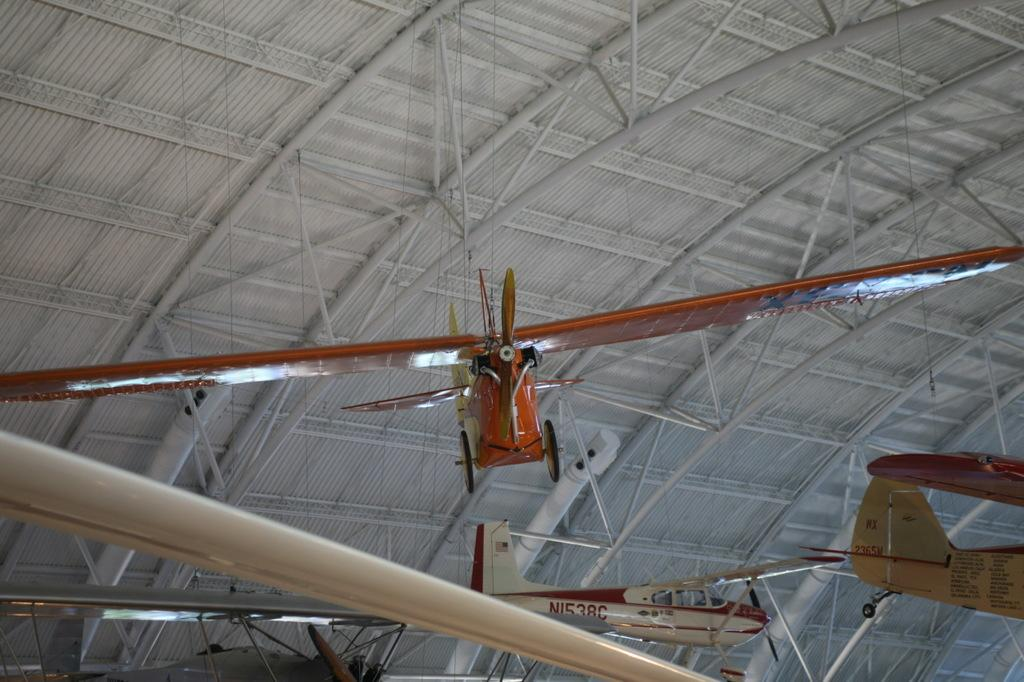What is the main subject of the image? The main subject of the image is airplanes. What other objects can be seen in the image? There are rods and a roof visible in the image. What arithmetic problem is being solved on the roof in the image? There is no arithmetic problem visible in the image, as it only features airplanes, rods, and a roof. 